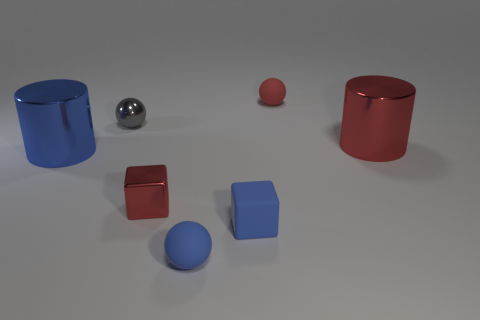Add 1 green cylinders. How many objects exist? 8 Subtract all cylinders. How many objects are left? 5 Add 6 tiny gray objects. How many tiny gray objects are left? 7 Add 3 tiny brown rubber cylinders. How many tiny brown rubber cylinders exist? 3 Subtract 0 brown blocks. How many objects are left? 7 Subtract all red metal things. Subtract all blue rubber balls. How many objects are left? 4 